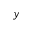Convert formula to latex. <formula><loc_0><loc_0><loc_500><loc_500>y</formula> 